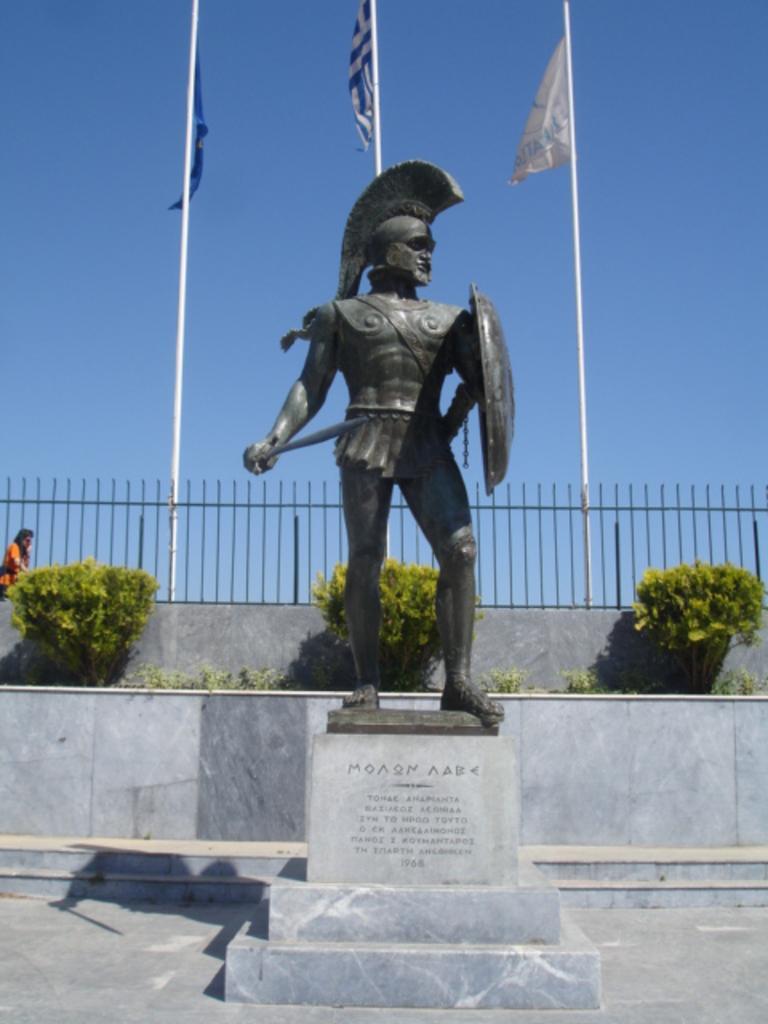How would you summarize this image in a sentence or two? In the center of the image we can see a statue placed on the ground with some text on it. In the background, we can see three flags on poles, metal railing, plants ,a person standing and the sky. 